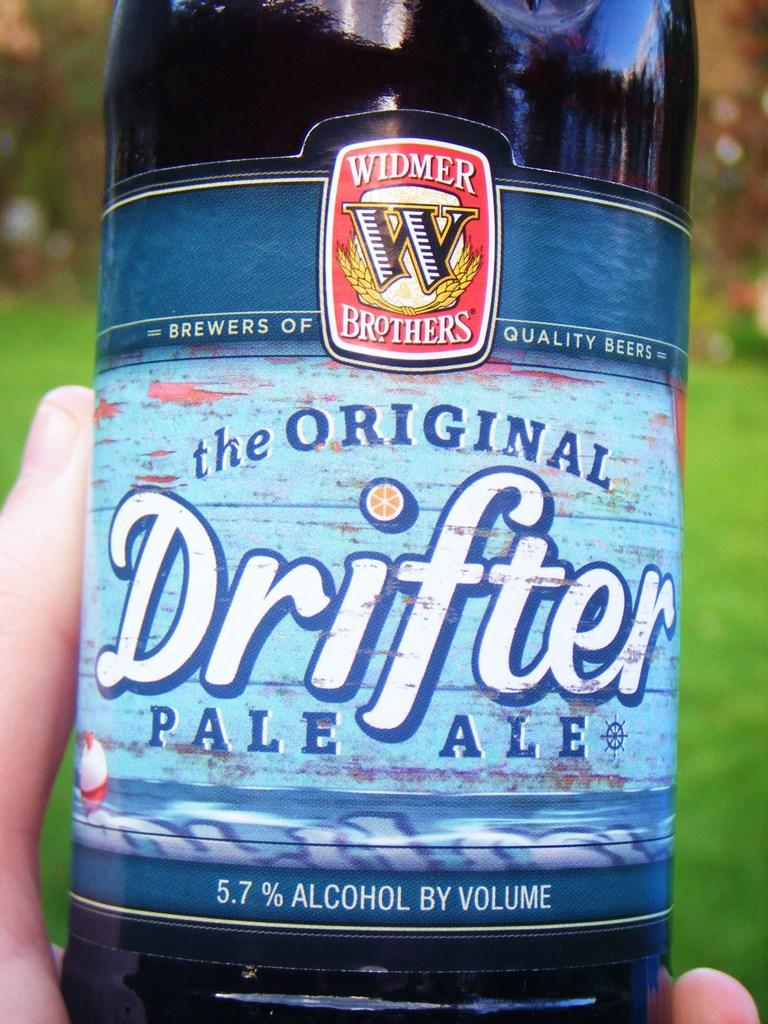<image>
Describe the image concisely. A bottle of the Oirginal Drifter Pale Ale is being held. 